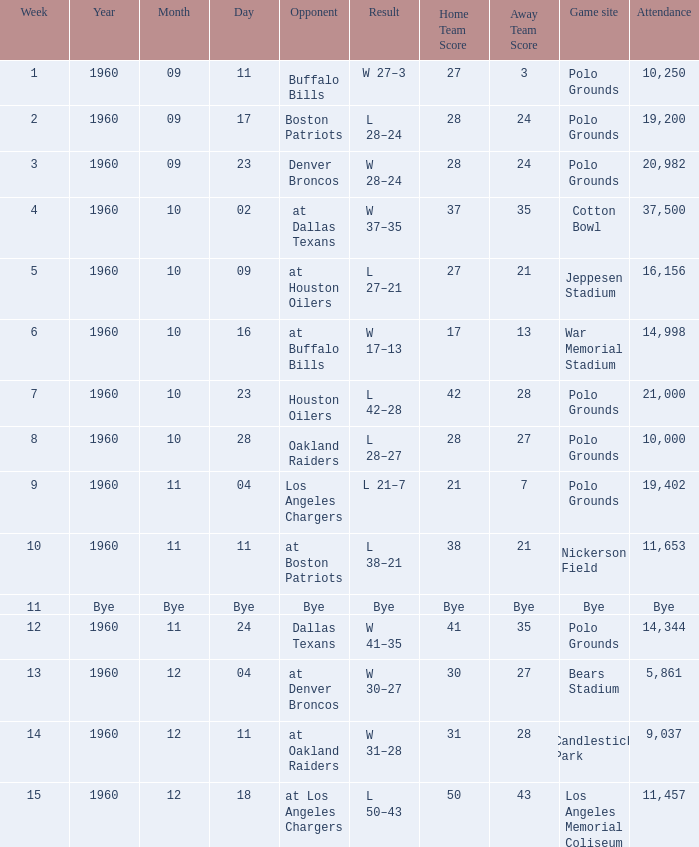What day did they play at candlestick park? 1960-12-11. 